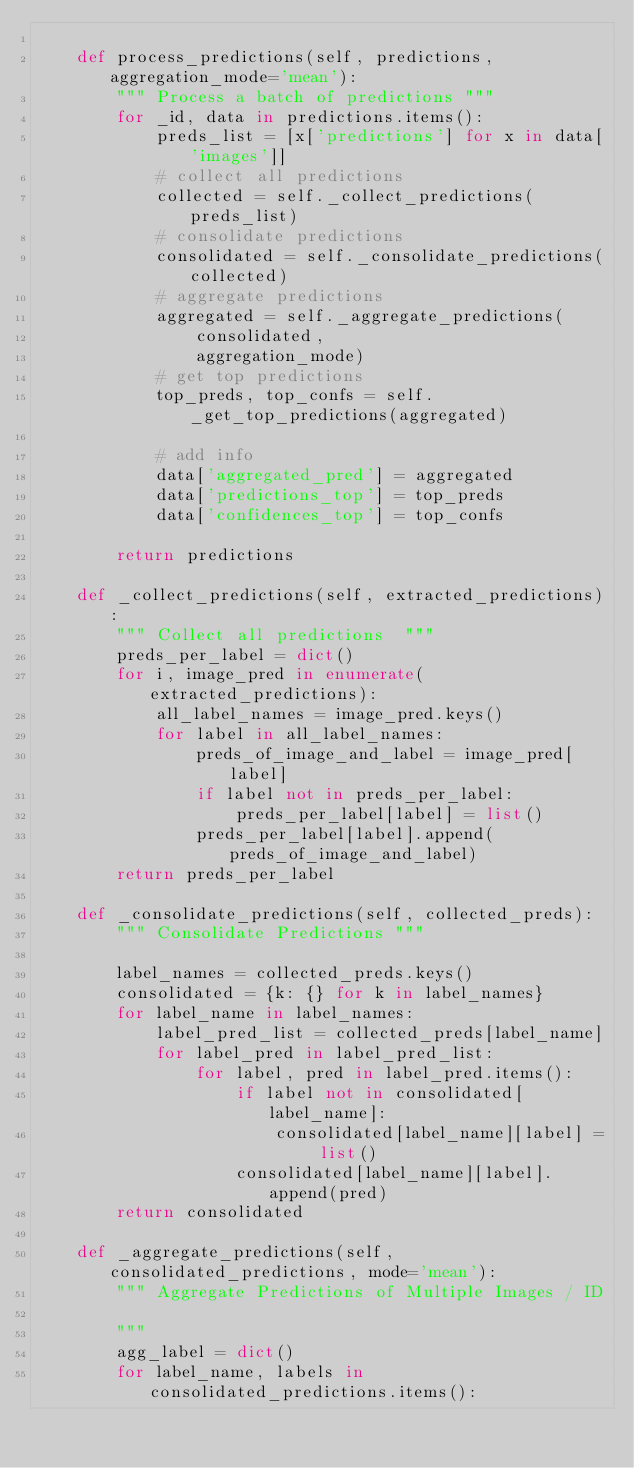Convert code to text. <code><loc_0><loc_0><loc_500><loc_500><_Python_>
    def process_predictions(self, predictions, aggregation_mode='mean'):
        """ Process a batch of predictions """
        for _id, data in predictions.items():
            preds_list = [x['predictions'] for x in data['images']]
            # collect all predictions
            collected = self._collect_predictions(preds_list)
            # consolidate predictions
            consolidated = self._consolidate_predictions(collected)
            # aggregate predictions
            aggregated = self._aggregate_predictions(
                consolidated,
                aggregation_mode)
            # get top predictions
            top_preds, top_confs = self._get_top_predictions(aggregated)

            # add info
            data['aggregated_pred'] = aggregated
            data['predictions_top'] = top_preds
            data['confidences_top'] = top_confs

        return predictions

    def _collect_predictions(self, extracted_predictions):
        """ Collect all predictions  """
        preds_per_label = dict()
        for i, image_pred in enumerate(extracted_predictions):
            all_label_names = image_pred.keys()
            for label in all_label_names:
                preds_of_image_and_label = image_pred[label]
                if label not in preds_per_label:
                    preds_per_label[label] = list()
                preds_per_label[label].append(preds_of_image_and_label)
        return preds_per_label

    def _consolidate_predictions(self, collected_preds):
        """ Consolidate Predictions """

        label_names = collected_preds.keys()
        consolidated = {k: {} for k in label_names}
        for label_name in label_names:
            label_pred_list = collected_preds[label_name]
            for label_pred in label_pred_list:
                for label, pred in label_pred.items():
                    if label not in consolidated[label_name]:
                        consolidated[label_name][label] = list()
                    consolidated[label_name][label].append(pred)
        return consolidated

    def _aggregate_predictions(self, consolidated_predictions, mode='mean'):
        """ Aggregate Predictions of Multiple Images / ID

        """
        agg_label = dict()
        for label_name, labels in consolidated_predictions.items():</code> 